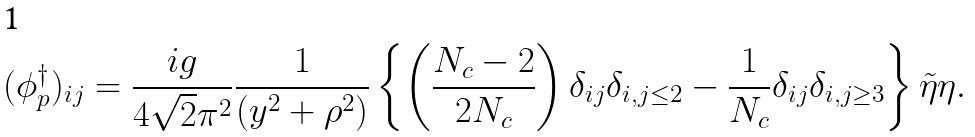Convert formula to latex. <formula><loc_0><loc_0><loc_500><loc_500>( \phi _ { p } ^ { \dagger } ) _ { i j } = \frac { i g } { 4 \sqrt { 2 } \pi ^ { 2 } } \frac { 1 } { ( y ^ { 2 } + \rho ^ { 2 } ) } \left \{ \left ( \frac { N _ { c } - 2 } { 2 N _ { c } } \right ) \delta _ { i j } \delta _ { i , j \leq 2 } - \frac { 1 } { N _ { c } } \delta _ { i j } \delta _ { i , j \geq 3 } \right \} \tilde { \eta } \eta .</formula> 